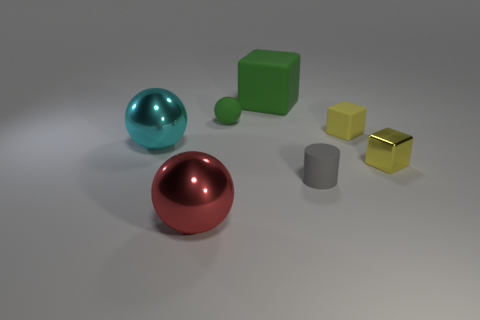How many objects are there in the image, and can you describe their colors? There are five objects in the image. Starting from the left, there is a teal-colored sphere, a large red sphere, a green cube, a small yellow cube, and a gray cylinder. Which object seems to be in front of all others? The red sphere is positioned closest to the front relative to the other objects. 